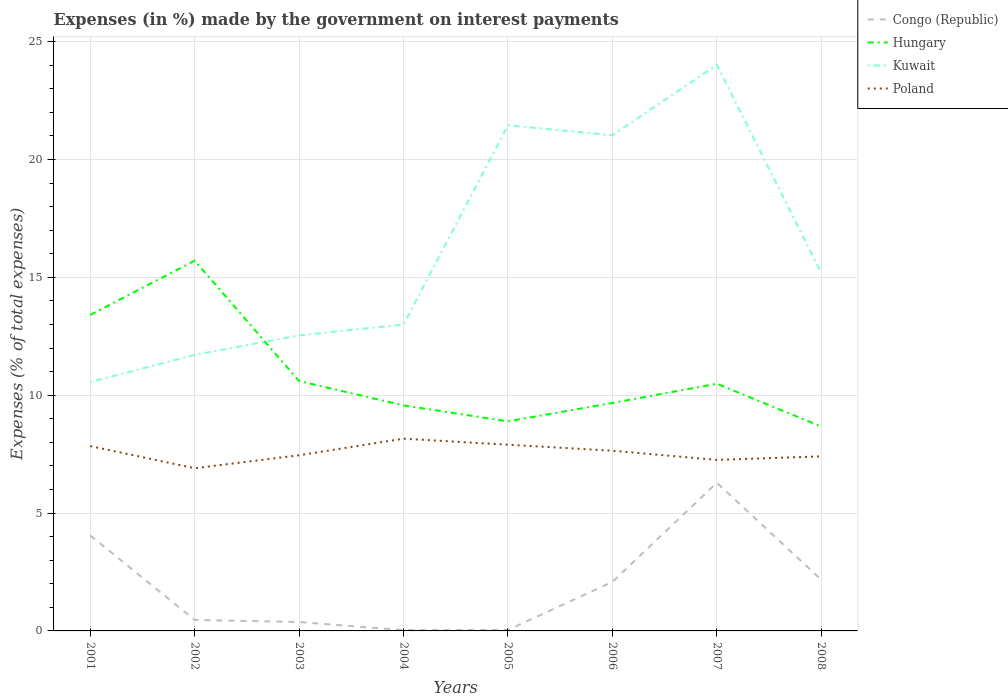Does the line corresponding to Hungary intersect with the line corresponding to Congo (Republic)?
Provide a short and direct response. No. Is the number of lines equal to the number of legend labels?
Provide a succinct answer. Yes. Across all years, what is the maximum percentage of expenses made by the government on interest payments in Kuwait?
Provide a succinct answer. 10.56. In which year was the percentage of expenses made by the government on interest payments in Congo (Republic) maximum?
Keep it short and to the point. 2004. What is the total percentage of expenses made by the government on interest payments in Congo (Republic) in the graph?
Ensure brevity in your answer.  4.02. What is the difference between the highest and the second highest percentage of expenses made by the government on interest payments in Kuwait?
Offer a terse response. 13.45. What is the difference between the highest and the lowest percentage of expenses made by the government on interest payments in Poland?
Provide a succinct answer. 4. How many lines are there?
Your answer should be compact. 4. Are the values on the major ticks of Y-axis written in scientific E-notation?
Offer a very short reply. No. Where does the legend appear in the graph?
Give a very brief answer. Top right. How many legend labels are there?
Offer a terse response. 4. How are the legend labels stacked?
Your response must be concise. Vertical. What is the title of the graph?
Ensure brevity in your answer.  Expenses (in %) made by the government on interest payments. What is the label or title of the Y-axis?
Offer a very short reply. Expenses (% of total expenses). What is the Expenses (% of total expenses) of Congo (Republic) in 2001?
Make the answer very short. 4.05. What is the Expenses (% of total expenses) in Hungary in 2001?
Provide a succinct answer. 13.41. What is the Expenses (% of total expenses) of Kuwait in 2001?
Provide a short and direct response. 10.56. What is the Expenses (% of total expenses) in Poland in 2001?
Ensure brevity in your answer.  7.84. What is the Expenses (% of total expenses) of Congo (Republic) in 2002?
Ensure brevity in your answer.  0.47. What is the Expenses (% of total expenses) in Hungary in 2002?
Offer a very short reply. 15.71. What is the Expenses (% of total expenses) in Kuwait in 2002?
Offer a very short reply. 11.71. What is the Expenses (% of total expenses) in Poland in 2002?
Ensure brevity in your answer.  6.9. What is the Expenses (% of total expenses) of Congo (Republic) in 2003?
Offer a terse response. 0.38. What is the Expenses (% of total expenses) in Hungary in 2003?
Make the answer very short. 10.6. What is the Expenses (% of total expenses) of Kuwait in 2003?
Keep it short and to the point. 12.54. What is the Expenses (% of total expenses) in Poland in 2003?
Make the answer very short. 7.45. What is the Expenses (% of total expenses) of Congo (Republic) in 2004?
Offer a very short reply. 0.03. What is the Expenses (% of total expenses) in Hungary in 2004?
Your response must be concise. 9.57. What is the Expenses (% of total expenses) in Kuwait in 2004?
Provide a succinct answer. 13. What is the Expenses (% of total expenses) of Poland in 2004?
Ensure brevity in your answer.  8.16. What is the Expenses (% of total expenses) in Congo (Republic) in 2005?
Offer a terse response. 0.04. What is the Expenses (% of total expenses) in Hungary in 2005?
Your answer should be compact. 8.89. What is the Expenses (% of total expenses) in Kuwait in 2005?
Keep it short and to the point. 21.45. What is the Expenses (% of total expenses) of Poland in 2005?
Your answer should be very brief. 7.9. What is the Expenses (% of total expenses) in Congo (Republic) in 2006?
Your answer should be compact. 2.08. What is the Expenses (% of total expenses) of Hungary in 2006?
Make the answer very short. 9.67. What is the Expenses (% of total expenses) in Kuwait in 2006?
Provide a short and direct response. 21.03. What is the Expenses (% of total expenses) in Poland in 2006?
Keep it short and to the point. 7.64. What is the Expenses (% of total expenses) in Congo (Republic) in 2007?
Provide a succinct answer. 6.29. What is the Expenses (% of total expenses) in Hungary in 2007?
Make the answer very short. 10.49. What is the Expenses (% of total expenses) in Kuwait in 2007?
Your answer should be compact. 24.01. What is the Expenses (% of total expenses) of Poland in 2007?
Provide a short and direct response. 7.26. What is the Expenses (% of total expenses) in Congo (Republic) in 2008?
Provide a succinct answer. 2.17. What is the Expenses (% of total expenses) in Hungary in 2008?
Provide a succinct answer. 8.67. What is the Expenses (% of total expenses) of Kuwait in 2008?
Your answer should be very brief. 15.19. What is the Expenses (% of total expenses) in Poland in 2008?
Offer a very short reply. 7.4. Across all years, what is the maximum Expenses (% of total expenses) in Congo (Republic)?
Your response must be concise. 6.29. Across all years, what is the maximum Expenses (% of total expenses) of Hungary?
Your response must be concise. 15.71. Across all years, what is the maximum Expenses (% of total expenses) in Kuwait?
Ensure brevity in your answer.  24.01. Across all years, what is the maximum Expenses (% of total expenses) of Poland?
Make the answer very short. 8.16. Across all years, what is the minimum Expenses (% of total expenses) in Congo (Republic)?
Offer a very short reply. 0.03. Across all years, what is the minimum Expenses (% of total expenses) in Hungary?
Offer a terse response. 8.67. Across all years, what is the minimum Expenses (% of total expenses) of Kuwait?
Ensure brevity in your answer.  10.56. Across all years, what is the minimum Expenses (% of total expenses) of Poland?
Your response must be concise. 6.9. What is the total Expenses (% of total expenses) of Congo (Republic) in the graph?
Provide a short and direct response. 15.5. What is the total Expenses (% of total expenses) in Hungary in the graph?
Offer a terse response. 86.99. What is the total Expenses (% of total expenses) in Kuwait in the graph?
Keep it short and to the point. 129.49. What is the total Expenses (% of total expenses) in Poland in the graph?
Offer a very short reply. 60.55. What is the difference between the Expenses (% of total expenses) of Congo (Republic) in 2001 and that in 2002?
Ensure brevity in your answer.  3.58. What is the difference between the Expenses (% of total expenses) in Kuwait in 2001 and that in 2002?
Your response must be concise. -1.15. What is the difference between the Expenses (% of total expenses) in Poland in 2001 and that in 2002?
Make the answer very short. 0.94. What is the difference between the Expenses (% of total expenses) of Congo (Republic) in 2001 and that in 2003?
Make the answer very short. 3.67. What is the difference between the Expenses (% of total expenses) in Hungary in 2001 and that in 2003?
Your answer should be compact. 2.8. What is the difference between the Expenses (% of total expenses) in Kuwait in 2001 and that in 2003?
Provide a succinct answer. -1.98. What is the difference between the Expenses (% of total expenses) in Poland in 2001 and that in 2003?
Give a very brief answer. 0.39. What is the difference between the Expenses (% of total expenses) in Congo (Republic) in 2001 and that in 2004?
Your answer should be very brief. 4.02. What is the difference between the Expenses (% of total expenses) in Hungary in 2001 and that in 2004?
Keep it short and to the point. 3.84. What is the difference between the Expenses (% of total expenses) in Kuwait in 2001 and that in 2004?
Your response must be concise. -2.44. What is the difference between the Expenses (% of total expenses) in Poland in 2001 and that in 2004?
Your answer should be compact. -0.31. What is the difference between the Expenses (% of total expenses) of Congo (Republic) in 2001 and that in 2005?
Give a very brief answer. 4.01. What is the difference between the Expenses (% of total expenses) of Hungary in 2001 and that in 2005?
Ensure brevity in your answer.  4.51. What is the difference between the Expenses (% of total expenses) in Kuwait in 2001 and that in 2005?
Offer a very short reply. -10.89. What is the difference between the Expenses (% of total expenses) in Poland in 2001 and that in 2005?
Offer a very short reply. -0.06. What is the difference between the Expenses (% of total expenses) in Congo (Republic) in 2001 and that in 2006?
Provide a succinct answer. 1.97. What is the difference between the Expenses (% of total expenses) of Hungary in 2001 and that in 2006?
Your answer should be compact. 3.73. What is the difference between the Expenses (% of total expenses) of Kuwait in 2001 and that in 2006?
Offer a very short reply. -10.47. What is the difference between the Expenses (% of total expenses) in Poland in 2001 and that in 2006?
Your response must be concise. 0.2. What is the difference between the Expenses (% of total expenses) of Congo (Republic) in 2001 and that in 2007?
Offer a terse response. -2.24. What is the difference between the Expenses (% of total expenses) of Hungary in 2001 and that in 2007?
Offer a very short reply. 2.92. What is the difference between the Expenses (% of total expenses) in Kuwait in 2001 and that in 2007?
Your response must be concise. -13.45. What is the difference between the Expenses (% of total expenses) of Poland in 2001 and that in 2007?
Provide a short and direct response. 0.59. What is the difference between the Expenses (% of total expenses) in Congo (Republic) in 2001 and that in 2008?
Give a very brief answer. 1.88. What is the difference between the Expenses (% of total expenses) of Hungary in 2001 and that in 2008?
Offer a very short reply. 4.73. What is the difference between the Expenses (% of total expenses) of Kuwait in 2001 and that in 2008?
Offer a very short reply. -4.63. What is the difference between the Expenses (% of total expenses) of Poland in 2001 and that in 2008?
Make the answer very short. 0.44. What is the difference between the Expenses (% of total expenses) of Congo (Republic) in 2002 and that in 2003?
Offer a very short reply. 0.09. What is the difference between the Expenses (% of total expenses) of Hungary in 2002 and that in 2003?
Offer a very short reply. 5.1. What is the difference between the Expenses (% of total expenses) in Kuwait in 2002 and that in 2003?
Give a very brief answer. -0.83. What is the difference between the Expenses (% of total expenses) in Poland in 2002 and that in 2003?
Keep it short and to the point. -0.55. What is the difference between the Expenses (% of total expenses) in Congo (Republic) in 2002 and that in 2004?
Your response must be concise. 0.43. What is the difference between the Expenses (% of total expenses) of Hungary in 2002 and that in 2004?
Provide a succinct answer. 6.14. What is the difference between the Expenses (% of total expenses) in Kuwait in 2002 and that in 2004?
Provide a succinct answer. -1.29. What is the difference between the Expenses (% of total expenses) of Poland in 2002 and that in 2004?
Ensure brevity in your answer.  -1.25. What is the difference between the Expenses (% of total expenses) in Congo (Republic) in 2002 and that in 2005?
Your response must be concise. 0.42. What is the difference between the Expenses (% of total expenses) of Hungary in 2002 and that in 2005?
Ensure brevity in your answer.  6.81. What is the difference between the Expenses (% of total expenses) in Kuwait in 2002 and that in 2005?
Ensure brevity in your answer.  -9.74. What is the difference between the Expenses (% of total expenses) of Poland in 2002 and that in 2005?
Provide a short and direct response. -1. What is the difference between the Expenses (% of total expenses) of Congo (Republic) in 2002 and that in 2006?
Provide a succinct answer. -1.61. What is the difference between the Expenses (% of total expenses) of Hungary in 2002 and that in 2006?
Make the answer very short. 6.03. What is the difference between the Expenses (% of total expenses) of Kuwait in 2002 and that in 2006?
Offer a terse response. -9.32. What is the difference between the Expenses (% of total expenses) in Poland in 2002 and that in 2006?
Provide a succinct answer. -0.74. What is the difference between the Expenses (% of total expenses) in Congo (Republic) in 2002 and that in 2007?
Keep it short and to the point. -5.82. What is the difference between the Expenses (% of total expenses) of Hungary in 2002 and that in 2007?
Offer a very short reply. 5.22. What is the difference between the Expenses (% of total expenses) in Kuwait in 2002 and that in 2007?
Offer a very short reply. -12.3. What is the difference between the Expenses (% of total expenses) in Poland in 2002 and that in 2007?
Your answer should be compact. -0.35. What is the difference between the Expenses (% of total expenses) in Congo (Republic) in 2002 and that in 2008?
Give a very brief answer. -1.71. What is the difference between the Expenses (% of total expenses) in Hungary in 2002 and that in 2008?
Your response must be concise. 7.03. What is the difference between the Expenses (% of total expenses) in Kuwait in 2002 and that in 2008?
Provide a short and direct response. -3.49. What is the difference between the Expenses (% of total expenses) in Poland in 2002 and that in 2008?
Keep it short and to the point. -0.5. What is the difference between the Expenses (% of total expenses) of Congo (Republic) in 2003 and that in 2004?
Offer a very short reply. 0.34. What is the difference between the Expenses (% of total expenses) in Hungary in 2003 and that in 2004?
Your answer should be very brief. 1.03. What is the difference between the Expenses (% of total expenses) of Kuwait in 2003 and that in 2004?
Provide a short and direct response. -0.46. What is the difference between the Expenses (% of total expenses) in Poland in 2003 and that in 2004?
Your answer should be very brief. -0.7. What is the difference between the Expenses (% of total expenses) of Congo (Republic) in 2003 and that in 2005?
Your response must be concise. 0.33. What is the difference between the Expenses (% of total expenses) in Hungary in 2003 and that in 2005?
Provide a succinct answer. 1.71. What is the difference between the Expenses (% of total expenses) in Kuwait in 2003 and that in 2005?
Give a very brief answer. -8.91. What is the difference between the Expenses (% of total expenses) of Poland in 2003 and that in 2005?
Provide a short and direct response. -0.45. What is the difference between the Expenses (% of total expenses) of Congo (Republic) in 2003 and that in 2006?
Your response must be concise. -1.7. What is the difference between the Expenses (% of total expenses) of Hungary in 2003 and that in 2006?
Provide a succinct answer. 0.93. What is the difference between the Expenses (% of total expenses) of Kuwait in 2003 and that in 2006?
Provide a short and direct response. -8.49. What is the difference between the Expenses (% of total expenses) of Poland in 2003 and that in 2006?
Make the answer very short. -0.19. What is the difference between the Expenses (% of total expenses) in Congo (Republic) in 2003 and that in 2007?
Provide a succinct answer. -5.91. What is the difference between the Expenses (% of total expenses) of Hungary in 2003 and that in 2007?
Your response must be concise. 0.11. What is the difference between the Expenses (% of total expenses) of Kuwait in 2003 and that in 2007?
Provide a succinct answer. -11.48. What is the difference between the Expenses (% of total expenses) of Poland in 2003 and that in 2007?
Provide a succinct answer. 0.2. What is the difference between the Expenses (% of total expenses) in Congo (Republic) in 2003 and that in 2008?
Keep it short and to the point. -1.8. What is the difference between the Expenses (% of total expenses) of Hungary in 2003 and that in 2008?
Ensure brevity in your answer.  1.93. What is the difference between the Expenses (% of total expenses) of Kuwait in 2003 and that in 2008?
Provide a short and direct response. -2.66. What is the difference between the Expenses (% of total expenses) of Poland in 2003 and that in 2008?
Keep it short and to the point. 0.05. What is the difference between the Expenses (% of total expenses) of Congo (Republic) in 2004 and that in 2005?
Give a very brief answer. -0.01. What is the difference between the Expenses (% of total expenses) of Hungary in 2004 and that in 2005?
Offer a terse response. 0.68. What is the difference between the Expenses (% of total expenses) of Kuwait in 2004 and that in 2005?
Offer a very short reply. -8.45. What is the difference between the Expenses (% of total expenses) in Poland in 2004 and that in 2005?
Provide a short and direct response. 0.26. What is the difference between the Expenses (% of total expenses) in Congo (Republic) in 2004 and that in 2006?
Offer a very short reply. -2.04. What is the difference between the Expenses (% of total expenses) of Hungary in 2004 and that in 2006?
Ensure brevity in your answer.  -0.1. What is the difference between the Expenses (% of total expenses) of Kuwait in 2004 and that in 2006?
Offer a very short reply. -8.03. What is the difference between the Expenses (% of total expenses) of Poland in 2004 and that in 2006?
Keep it short and to the point. 0.51. What is the difference between the Expenses (% of total expenses) in Congo (Republic) in 2004 and that in 2007?
Provide a short and direct response. -6.25. What is the difference between the Expenses (% of total expenses) of Hungary in 2004 and that in 2007?
Your response must be concise. -0.92. What is the difference between the Expenses (% of total expenses) in Kuwait in 2004 and that in 2007?
Keep it short and to the point. -11.02. What is the difference between the Expenses (% of total expenses) of Poland in 2004 and that in 2007?
Your answer should be very brief. 0.9. What is the difference between the Expenses (% of total expenses) of Congo (Republic) in 2004 and that in 2008?
Ensure brevity in your answer.  -2.14. What is the difference between the Expenses (% of total expenses) in Hungary in 2004 and that in 2008?
Offer a very short reply. 0.89. What is the difference between the Expenses (% of total expenses) of Kuwait in 2004 and that in 2008?
Ensure brevity in your answer.  -2.2. What is the difference between the Expenses (% of total expenses) of Poland in 2004 and that in 2008?
Give a very brief answer. 0.75. What is the difference between the Expenses (% of total expenses) in Congo (Republic) in 2005 and that in 2006?
Make the answer very short. -2.04. What is the difference between the Expenses (% of total expenses) in Hungary in 2005 and that in 2006?
Give a very brief answer. -0.78. What is the difference between the Expenses (% of total expenses) of Kuwait in 2005 and that in 2006?
Make the answer very short. 0.42. What is the difference between the Expenses (% of total expenses) of Poland in 2005 and that in 2006?
Make the answer very short. 0.25. What is the difference between the Expenses (% of total expenses) in Congo (Republic) in 2005 and that in 2007?
Ensure brevity in your answer.  -6.24. What is the difference between the Expenses (% of total expenses) in Hungary in 2005 and that in 2007?
Offer a terse response. -1.6. What is the difference between the Expenses (% of total expenses) of Kuwait in 2005 and that in 2007?
Your answer should be compact. -2.56. What is the difference between the Expenses (% of total expenses) in Poland in 2005 and that in 2007?
Give a very brief answer. 0.64. What is the difference between the Expenses (% of total expenses) in Congo (Republic) in 2005 and that in 2008?
Ensure brevity in your answer.  -2.13. What is the difference between the Expenses (% of total expenses) in Hungary in 2005 and that in 2008?
Your answer should be very brief. 0.22. What is the difference between the Expenses (% of total expenses) of Kuwait in 2005 and that in 2008?
Offer a terse response. 6.26. What is the difference between the Expenses (% of total expenses) of Poland in 2005 and that in 2008?
Your response must be concise. 0.49. What is the difference between the Expenses (% of total expenses) of Congo (Republic) in 2006 and that in 2007?
Your response must be concise. -4.21. What is the difference between the Expenses (% of total expenses) of Hungary in 2006 and that in 2007?
Offer a very short reply. -0.82. What is the difference between the Expenses (% of total expenses) in Kuwait in 2006 and that in 2007?
Ensure brevity in your answer.  -2.99. What is the difference between the Expenses (% of total expenses) in Poland in 2006 and that in 2007?
Provide a succinct answer. 0.39. What is the difference between the Expenses (% of total expenses) in Congo (Republic) in 2006 and that in 2008?
Provide a short and direct response. -0.09. What is the difference between the Expenses (% of total expenses) in Hungary in 2006 and that in 2008?
Keep it short and to the point. 1. What is the difference between the Expenses (% of total expenses) in Kuwait in 2006 and that in 2008?
Your answer should be compact. 5.83. What is the difference between the Expenses (% of total expenses) of Poland in 2006 and that in 2008?
Your answer should be very brief. 0.24. What is the difference between the Expenses (% of total expenses) of Congo (Republic) in 2007 and that in 2008?
Make the answer very short. 4.11. What is the difference between the Expenses (% of total expenses) in Hungary in 2007 and that in 2008?
Keep it short and to the point. 1.82. What is the difference between the Expenses (% of total expenses) in Kuwait in 2007 and that in 2008?
Provide a succinct answer. 8.82. What is the difference between the Expenses (% of total expenses) of Poland in 2007 and that in 2008?
Provide a short and direct response. -0.15. What is the difference between the Expenses (% of total expenses) of Congo (Republic) in 2001 and the Expenses (% of total expenses) of Hungary in 2002?
Offer a very short reply. -11.66. What is the difference between the Expenses (% of total expenses) of Congo (Republic) in 2001 and the Expenses (% of total expenses) of Kuwait in 2002?
Provide a short and direct response. -7.66. What is the difference between the Expenses (% of total expenses) of Congo (Republic) in 2001 and the Expenses (% of total expenses) of Poland in 2002?
Give a very brief answer. -2.85. What is the difference between the Expenses (% of total expenses) in Hungary in 2001 and the Expenses (% of total expenses) in Kuwait in 2002?
Your response must be concise. 1.7. What is the difference between the Expenses (% of total expenses) in Hungary in 2001 and the Expenses (% of total expenses) in Poland in 2002?
Keep it short and to the point. 6.5. What is the difference between the Expenses (% of total expenses) in Kuwait in 2001 and the Expenses (% of total expenses) in Poland in 2002?
Ensure brevity in your answer.  3.66. What is the difference between the Expenses (% of total expenses) of Congo (Republic) in 2001 and the Expenses (% of total expenses) of Hungary in 2003?
Offer a very short reply. -6.55. What is the difference between the Expenses (% of total expenses) in Congo (Republic) in 2001 and the Expenses (% of total expenses) in Kuwait in 2003?
Keep it short and to the point. -8.49. What is the difference between the Expenses (% of total expenses) of Congo (Republic) in 2001 and the Expenses (% of total expenses) of Poland in 2003?
Give a very brief answer. -3.4. What is the difference between the Expenses (% of total expenses) in Hungary in 2001 and the Expenses (% of total expenses) in Kuwait in 2003?
Offer a very short reply. 0.87. What is the difference between the Expenses (% of total expenses) of Hungary in 2001 and the Expenses (% of total expenses) of Poland in 2003?
Provide a short and direct response. 5.95. What is the difference between the Expenses (% of total expenses) of Kuwait in 2001 and the Expenses (% of total expenses) of Poland in 2003?
Keep it short and to the point. 3.11. What is the difference between the Expenses (% of total expenses) in Congo (Republic) in 2001 and the Expenses (% of total expenses) in Hungary in 2004?
Your response must be concise. -5.52. What is the difference between the Expenses (% of total expenses) in Congo (Republic) in 2001 and the Expenses (% of total expenses) in Kuwait in 2004?
Keep it short and to the point. -8.95. What is the difference between the Expenses (% of total expenses) of Congo (Republic) in 2001 and the Expenses (% of total expenses) of Poland in 2004?
Provide a succinct answer. -4.11. What is the difference between the Expenses (% of total expenses) of Hungary in 2001 and the Expenses (% of total expenses) of Kuwait in 2004?
Ensure brevity in your answer.  0.41. What is the difference between the Expenses (% of total expenses) in Hungary in 2001 and the Expenses (% of total expenses) in Poland in 2004?
Your answer should be very brief. 5.25. What is the difference between the Expenses (% of total expenses) of Kuwait in 2001 and the Expenses (% of total expenses) of Poland in 2004?
Ensure brevity in your answer.  2.4. What is the difference between the Expenses (% of total expenses) in Congo (Republic) in 2001 and the Expenses (% of total expenses) in Hungary in 2005?
Ensure brevity in your answer.  -4.84. What is the difference between the Expenses (% of total expenses) of Congo (Republic) in 2001 and the Expenses (% of total expenses) of Kuwait in 2005?
Ensure brevity in your answer.  -17.4. What is the difference between the Expenses (% of total expenses) in Congo (Republic) in 2001 and the Expenses (% of total expenses) in Poland in 2005?
Make the answer very short. -3.85. What is the difference between the Expenses (% of total expenses) of Hungary in 2001 and the Expenses (% of total expenses) of Kuwait in 2005?
Provide a succinct answer. -8.04. What is the difference between the Expenses (% of total expenses) of Hungary in 2001 and the Expenses (% of total expenses) of Poland in 2005?
Keep it short and to the point. 5.51. What is the difference between the Expenses (% of total expenses) in Kuwait in 2001 and the Expenses (% of total expenses) in Poland in 2005?
Offer a very short reply. 2.66. What is the difference between the Expenses (% of total expenses) of Congo (Republic) in 2001 and the Expenses (% of total expenses) of Hungary in 2006?
Ensure brevity in your answer.  -5.62. What is the difference between the Expenses (% of total expenses) of Congo (Republic) in 2001 and the Expenses (% of total expenses) of Kuwait in 2006?
Your answer should be compact. -16.98. What is the difference between the Expenses (% of total expenses) in Congo (Republic) in 2001 and the Expenses (% of total expenses) in Poland in 2006?
Provide a short and direct response. -3.6. What is the difference between the Expenses (% of total expenses) of Hungary in 2001 and the Expenses (% of total expenses) of Kuwait in 2006?
Keep it short and to the point. -7.62. What is the difference between the Expenses (% of total expenses) of Hungary in 2001 and the Expenses (% of total expenses) of Poland in 2006?
Offer a terse response. 5.76. What is the difference between the Expenses (% of total expenses) in Kuwait in 2001 and the Expenses (% of total expenses) in Poland in 2006?
Provide a succinct answer. 2.92. What is the difference between the Expenses (% of total expenses) of Congo (Republic) in 2001 and the Expenses (% of total expenses) of Hungary in 2007?
Keep it short and to the point. -6.44. What is the difference between the Expenses (% of total expenses) in Congo (Republic) in 2001 and the Expenses (% of total expenses) in Kuwait in 2007?
Ensure brevity in your answer.  -19.96. What is the difference between the Expenses (% of total expenses) of Congo (Republic) in 2001 and the Expenses (% of total expenses) of Poland in 2007?
Offer a very short reply. -3.21. What is the difference between the Expenses (% of total expenses) of Hungary in 2001 and the Expenses (% of total expenses) of Kuwait in 2007?
Provide a short and direct response. -10.61. What is the difference between the Expenses (% of total expenses) in Hungary in 2001 and the Expenses (% of total expenses) in Poland in 2007?
Your response must be concise. 6.15. What is the difference between the Expenses (% of total expenses) in Kuwait in 2001 and the Expenses (% of total expenses) in Poland in 2007?
Provide a short and direct response. 3.31. What is the difference between the Expenses (% of total expenses) in Congo (Republic) in 2001 and the Expenses (% of total expenses) in Hungary in 2008?
Keep it short and to the point. -4.62. What is the difference between the Expenses (% of total expenses) of Congo (Republic) in 2001 and the Expenses (% of total expenses) of Kuwait in 2008?
Keep it short and to the point. -11.15. What is the difference between the Expenses (% of total expenses) of Congo (Republic) in 2001 and the Expenses (% of total expenses) of Poland in 2008?
Give a very brief answer. -3.36. What is the difference between the Expenses (% of total expenses) of Hungary in 2001 and the Expenses (% of total expenses) of Kuwait in 2008?
Ensure brevity in your answer.  -1.79. What is the difference between the Expenses (% of total expenses) in Hungary in 2001 and the Expenses (% of total expenses) in Poland in 2008?
Ensure brevity in your answer.  6. What is the difference between the Expenses (% of total expenses) of Kuwait in 2001 and the Expenses (% of total expenses) of Poland in 2008?
Keep it short and to the point. 3.16. What is the difference between the Expenses (% of total expenses) in Congo (Republic) in 2002 and the Expenses (% of total expenses) in Hungary in 2003?
Your answer should be very brief. -10.13. What is the difference between the Expenses (% of total expenses) in Congo (Republic) in 2002 and the Expenses (% of total expenses) in Kuwait in 2003?
Your answer should be very brief. -12.07. What is the difference between the Expenses (% of total expenses) in Congo (Republic) in 2002 and the Expenses (% of total expenses) in Poland in 2003?
Make the answer very short. -6.99. What is the difference between the Expenses (% of total expenses) in Hungary in 2002 and the Expenses (% of total expenses) in Kuwait in 2003?
Provide a succinct answer. 3.17. What is the difference between the Expenses (% of total expenses) in Hungary in 2002 and the Expenses (% of total expenses) in Poland in 2003?
Offer a terse response. 8.25. What is the difference between the Expenses (% of total expenses) in Kuwait in 2002 and the Expenses (% of total expenses) in Poland in 2003?
Give a very brief answer. 4.26. What is the difference between the Expenses (% of total expenses) in Congo (Republic) in 2002 and the Expenses (% of total expenses) in Hungary in 2004?
Keep it short and to the point. -9.1. What is the difference between the Expenses (% of total expenses) of Congo (Republic) in 2002 and the Expenses (% of total expenses) of Kuwait in 2004?
Offer a terse response. -12.53. What is the difference between the Expenses (% of total expenses) in Congo (Republic) in 2002 and the Expenses (% of total expenses) in Poland in 2004?
Ensure brevity in your answer.  -7.69. What is the difference between the Expenses (% of total expenses) of Hungary in 2002 and the Expenses (% of total expenses) of Kuwait in 2004?
Give a very brief answer. 2.71. What is the difference between the Expenses (% of total expenses) of Hungary in 2002 and the Expenses (% of total expenses) of Poland in 2004?
Offer a very short reply. 7.55. What is the difference between the Expenses (% of total expenses) of Kuwait in 2002 and the Expenses (% of total expenses) of Poland in 2004?
Your answer should be very brief. 3.55. What is the difference between the Expenses (% of total expenses) in Congo (Republic) in 2002 and the Expenses (% of total expenses) in Hungary in 2005?
Provide a succinct answer. -8.42. What is the difference between the Expenses (% of total expenses) in Congo (Republic) in 2002 and the Expenses (% of total expenses) in Kuwait in 2005?
Offer a very short reply. -20.98. What is the difference between the Expenses (% of total expenses) in Congo (Republic) in 2002 and the Expenses (% of total expenses) in Poland in 2005?
Provide a short and direct response. -7.43. What is the difference between the Expenses (% of total expenses) of Hungary in 2002 and the Expenses (% of total expenses) of Kuwait in 2005?
Your answer should be very brief. -5.74. What is the difference between the Expenses (% of total expenses) of Hungary in 2002 and the Expenses (% of total expenses) of Poland in 2005?
Offer a very short reply. 7.81. What is the difference between the Expenses (% of total expenses) of Kuwait in 2002 and the Expenses (% of total expenses) of Poland in 2005?
Offer a very short reply. 3.81. What is the difference between the Expenses (% of total expenses) in Congo (Republic) in 2002 and the Expenses (% of total expenses) in Hungary in 2006?
Make the answer very short. -9.2. What is the difference between the Expenses (% of total expenses) of Congo (Republic) in 2002 and the Expenses (% of total expenses) of Kuwait in 2006?
Make the answer very short. -20.56. What is the difference between the Expenses (% of total expenses) of Congo (Republic) in 2002 and the Expenses (% of total expenses) of Poland in 2006?
Keep it short and to the point. -7.18. What is the difference between the Expenses (% of total expenses) of Hungary in 2002 and the Expenses (% of total expenses) of Kuwait in 2006?
Provide a succinct answer. -5.32. What is the difference between the Expenses (% of total expenses) of Hungary in 2002 and the Expenses (% of total expenses) of Poland in 2006?
Your answer should be very brief. 8.06. What is the difference between the Expenses (% of total expenses) in Kuwait in 2002 and the Expenses (% of total expenses) in Poland in 2006?
Offer a terse response. 4.06. What is the difference between the Expenses (% of total expenses) in Congo (Republic) in 2002 and the Expenses (% of total expenses) in Hungary in 2007?
Offer a very short reply. -10.02. What is the difference between the Expenses (% of total expenses) in Congo (Republic) in 2002 and the Expenses (% of total expenses) in Kuwait in 2007?
Your response must be concise. -23.55. What is the difference between the Expenses (% of total expenses) of Congo (Republic) in 2002 and the Expenses (% of total expenses) of Poland in 2007?
Ensure brevity in your answer.  -6.79. What is the difference between the Expenses (% of total expenses) of Hungary in 2002 and the Expenses (% of total expenses) of Kuwait in 2007?
Your answer should be very brief. -8.31. What is the difference between the Expenses (% of total expenses) in Hungary in 2002 and the Expenses (% of total expenses) in Poland in 2007?
Offer a very short reply. 8.45. What is the difference between the Expenses (% of total expenses) of Kuwait in 2002 and the Expenses (% of total expenses) of Poland in 2007?
Ensure brevity in your answer.  4.45. What is the difference between the Expenses (% of total expenses) of Congo (Republic) in 2002 and the Expenses (% of total expenses) of Hungary in 2008?
Offer a terse response. -8.2. What is the difference between the Expenses (% of total expenses) in Congo (Republic) in 2002 and the Expenses (% of total expenses) in Kuwait in 2008?
Give a very brief answer. -14.73. What is the difference between the Expenses (% of total expenses) in Congo (Republic) in 2002 and the Expenses (% of total expenses) in Poland in 2008?
Offer a very short reply. -6.94. What is the difference between the Expenses (% of total expenses) of Hungary in 2002 and the Expenses (% of total expenses) of Kuwait in 2008?
Provide a short and direct response. 0.51. What is the difference between the Expenses (% of total expenses) of Hungary in 2002 and the Expenses (% of total expenses) of Poland in 2008?
Your response must be concise. 8.3. What is the difference between the Expenses (% of total expenses) of Kuwait in 2002 and the Expenses (% of total expenses) of Poland in 2008?
Your answer should be compact. 4.3. What is the difference between the Expenses (% of total expenses) of Congo (Republic) in 2003 and the Expenses (% of total expenses) of Hungary in 2004?
Your answer should be compact. -9.19. What is the difference between the Expenses (% of total expenses) of Congo (Republic) in 2003 and the Expenses (% of total expenses) of Kuwait in 2004?
Offer a terse response. -12.62. What is the difference between the Expenses (% of total expenses) of Congo (Republic) in 2003 and the Expenses (% of total expenses) of Poland in 2004?
Provide a succinct answer. -7.78. What is the difference between the Expenses (% of total expenses) in Hungary in 2003 and the Expenses (% of total expenses) in Kuwait in 2004?
Your response must be concise. -2.4. What is the difference between the Expenses (% of total expenses) in Hungary in 2003 and the Expenses (% of total expenses) in Poland in 2004?
Offer a very short reply. 2.45. What is the difference between the Expenses (% of total expenses) in Kuwait in 2003 and the Expenses (% of total expenses) in Poland in 2004?
Your answer should be compact. 4.38. What is the difference between the Expenses (% of total expenses) in Congo (Republic) in 2003 and the Expenses (% of total expenses) in Hungary in 2005?
Offer a terse response. -8.51. What is the difference between the Expenses (% of total expenses) of Congo (Republic) in 2003 and the Expenses (% of total expenses) of Kuwait in 2005?
Offer a very short reply. -21.07. What is the difference between the Expenses (% of total expenses) in Congo (Republic) in 2003 and the Expenses (% of total expenses) in Poland in 2005?
Your answer should be compact. -7.52. What is the difference between the Expenses (% of total expenses) of Hungary in 2003 and the Expenses (% of total expenses) of Kuwait in 2005?
Your answer should be very brief. -10.85. What is the difference between the Expenses (% of total expenses) in Hungary in 2003 and the Expenses (% of total expenses) in Poland in 2005?
Your answer should be compact. 2.7. What is the difference between the Expenses (% of total expenses) in Kuwait in 2003 and the Expenses (% of total expenses) in Poland in 2005?
Ensure brevity in your answer.  4.64. What is the difference between the Expenses (% of total expenses) in Congo (Republic) in 2003 and the Expenses (% of total expenses) in Hungary in 2006?
Ensure brevity in your answer.  -9.29. What is the difference between the Expenses (% of total expenses) of Congo (Republic) in 2003 and the Expenses (% of total expenses) of Kuwait in 2006?
Provide a short and direct response. -20.65. What is the difference between the Expenses (% of total expenses) in Congo (Republic) in 2003 and the Expenses (% of total expenses) in Poland in 2006?
Ensure brevity in your answer.  -7.27. What is the difference between the Expenses (% of total expenses) of Hungary in 2003 and the Expenses (% of total expenses) of Kuwait in 2006?
Offer a very short reply. -10.43. What is the difference between the Expenses (% of total expenses) in Hungary in 2003 and the Expenses (% of total expenses) in Poland in 2006?
Your answer should be very brief. 2.96. What is the difference between the Expenses (% of total expenses) of Kuwait in 2003 and the Expenses (% of total expenses) of Poland in 2006?
Ensure brevity in your answer.  4.89. What is the difference between the Expenses (% of total expenses) in Congo (Republic) in 2003 and the Expenses (% of total expenses) in Hungary in 2007?
Provide a succinct answer. -10.11. What is the difference between the Expenses (% of total expenses) in Congo (Republic) in 2003 and the Expenses (% of total expenses) in Kuwait in 2007?
Provide a short and direct response. -23.64. What is the difference between the Expenses (% of total expenses) in Congo (Republic) in 2003 and the Expenses (% of total expenses) in Poland in 2007?
Your response must be concise. -6.88. What is the difference between the Expenses (% of total expenses) in Hungary in 2003 and the Expenses (% of total expenses) in Kuwait in 2007?
Ensure brevity in your answer.  -13.41. What is the difference between the Expenses (% of total expenses) in Hungary in 2003 and the Expenses (% of total expenses) in Poland in 2007?
Provide a short and direct response. 3.35. What is the difference between the Expenses (% of total expenses) in Kuwait in 2003 and the Expenses (% of total expenses) in Poland in 2007?
Provide a short and direct response. 5.28. What is the difference between the Expenses (% of total expenses) of Congo (Republic) in 2003 and the Expenses (% of total expenses) of Hungary in 2008?
Your answer should be compact. -8.29. What is the difference between the Expenses (% of total expenses) in Congo (Republic) in 2003 and the Expenses (% of total expenses) in Kuwait in 2008?
Provide a short and direct response. -14.82. What is the difference between the Expenses (% of total expenses) in Congo (Republic) in 2003 and the Expenses (% of total expenses) in Poland in 2008?
Offer a terse response. -7.03. What is the difference between the Expenses (% of total expenses) in Hungary in 2003 and the Expenses (% of total expenses) in Kuwait in 2008?
Keep it short and to the point. -4.59. What is the difference between the Expenses (% of total expenses) in Hungary in 2003 and the Expenses (% of total expenses) in Poland in 2008?
Give a very brief answer. 3.2. What is the difference between the Expenses (% of total expenses) in Kuwait in 2003 and the Expenses (% of total expenses) in Poland in 2008?
Your answer should be compact. 5.13. What is the difference between the Expenses (% of total expenses) of Congo (Republic) in 2004 and the Expenses (% of total expenses) of Hungary in 2005?
Your answer should be compact. -8.86. What is the difference between the Expenses (% of total expenses) in Congo (Republic) in 2004 and the Expenses (% of total expenses) in Kuwait in 2005?
Provide a succinct answer. -21.42. What is the difference between the Expenses (% of total expenses) in Congo (Republic) in 2004 and the Expenses (% of total expenses) in Poland in 2005?
Provide a succinct answer. -7.87. What is the difference between the Expenses (% of total expenses) in Hungary in 2004 and the Expenses (% of total expenses) in Kuwait in 2005?
Your response must be concise. -11.88. What is the difference between the Expenses (% of total expenses) in Hungary in 2004 and the Expenses (% of total expenses) in Poland in 2005?
Offer a very short reply. 1.67. What is the difference between the Expenses (% of total expenses) in Kuwait in 2004 and the Expenses (% of total expenses) in Poland in 2005?
Ensure brevity in your answer.  5.1. What is the difference between the Expenses (% of total expenses) of Congo (Republic) in 2004 and the Expenses (% of total expenses) of Hungary in 2006?
Make the answer very short. -9.64. What is the difference between the Expenses (% of total expenses) of Congo (Republic) in 2004 and the Expenses (% of total expenses) of Kuwait in 2006?
Give a very brief answer. -20.99. What is the difference between the Expenses (% of total expenses) in Congo (Republic) in 2004 and the Expenses (% of total expenses) in Poland in 2006?
Your response must be concise. -7.61. What is the difference between the Expenses (% of total expenses) of Hungary in 2004 and the Expenses (% of total expenses) of Kuwait in 2006?
Provide a succinct answer. -11.46. What is the difference between the Expenses (% of total expenses) in Hungary in 2004 and the Expenses (% of total expenses) in Poland in 2006?
Offer a terse response. 1.92. What is the difference between the Expenses (% of total expenses) in Kuwait in 2004 and the Expenses (% of total expenses) in Poland in 2006?
Ensure brevity in your answer.  5.35. What is the difference between the Expenses (% of total expenses) of Congo (Republic) in 2004 and the Expenses (% of total expenses) of Hungary in 2007?
Provide a short and direct response. -10.45. What is the difference between the Expenses (% of total expenses) of Congo (Republic) in 2004 and the Expenses (% of total expenses) of Kuwait in 2007?
Keep it short and to the point. -23.98. What is the difference between the Expenses (% of total expenses) of Congo (Republic) in 2004 and the Expenses (% of total expenses) of Poland in 2007?
Keep it short and to the point. -7.22. What is the difference between the Expenses (% of total expenses) in Hungary in 2004 and the Expenses (% of total expenses) in Kuwait in 2007?
Provide a short and direct response. -14.45. What is the difference between the Expenses (% of total expenses) of Hungary in 2004 and the Expenses (% of total expenses) of Poland in 2007?
Keep it short and to the point. 2.31. What is the difference between the Expenses (% of total expenses) in Kuwait in 2004 and the Expenses (% of total expenses) in Poland in 2007?
Make the answer very short. 5.74. What is the difference between the Expenses (% of total expenses) of Congo (Republic) in 2004 and the Expenses (% of total expenses) of Hungary in 2008?
Provide a succinct answer. -8.64. What is the difference between the Expenses (% of total expenses) of Congo (Republic) in 2004 and the Expenses (% of total expenses) of Kuwait in 2008?
Offer a very short reply. -15.16. What is the difference between the Expenses (% of total expenses) of Congo (Republic) in 2004 and the Expenses (% of total expenses) of Poland in 2008?
Offer a very short reply. -7.37. What is the difference between the Expenses (% of total expenses) of Hungary in 2004 and the Expenses (% of total expenses) of Kuwait in 2008?
Offer a very short reply. -5.63. What is the difference between the Expenses (% of total expenses) of Hungary in 2004 and the Expenses (% of total expenses) of Poland in 2008?
Provide a succinct answer. 2.16. What is the difference between the Expenses (% of total expenses) of Kuwait in 2004 and the Expenses (% of total expenses) of Poland in 2008?
Ensure brevity in your answer.  5.59. What is the difference between the Expenses (% of total expenses) in Congo (Republic) in 2005 and the Expenses (% of total expenses) in Hungary in 2006?
Provide a succinct answer. -9.63. What is the difference between the Expenses (% of total expenses) of Congo (Republic) in 2005 and the Expenses (% of total expenses) of Kuwait in 2006?
Ensure brevity in your answer.  -20.99. What is the difference between the Expenses (% of total expenses) of Congo (Republic) in 2005 and the Expenses (% of total expenses) of Poland in 2006?
Give a very brief answer. -7.6. What is the difference between the Expenses (% of total expenses) of Hungary in 2005 and the Expenses (% of total expenses) of Kuwait in 2006?
Provide a short and direct response. -12.14. What is the difference between the Expenses (% of total expenses) of Hungary in 2005 and the Expenses (% of total expenses) of Poland in 2006?
Your answer should be compact. 1.25. What is the difference between the Expenses (% of total expenses) in Kuwait in 2005 and the Expenses (% of total expenses) in Poland in 2006?
Offer a very short reply. 13.8. What is the difference between the Expenses (% of total expenses) in Congo (Republic) in 2005 and the Expenses (% of total expenses) in Hungary in 2007?
Provide a short and direct response. -10.44. What is the difference between the Expenses (% of total expenses) in Congo (Republic) in 2005 and the Expenses (% of total expenses) in Kuwait in 2007?
Offer a terse response. -23.97. What is the difference between the Expenses (% of total expenses) in Congo (Republic) in 2005 and the Expenses (% of total expenses) in Poland in 2007?
Ensure brevity in your answer.  -7.21. What is the difference between the Expenses (% of total expenses) in Hungary in 2005 and the Expenses (% of total expenses) in Kuwait in 2007?
Keep it short and to the point. -15.12. What is the difference between the Expenses (% of total expenses) of Hungary in 2005 and the Expenses (% of total expenses) of Poland in 2007?
Provide a succinct answer. 1.64. What is the difference between the Expenses (% of total expenses) in Kuwait in 2005 and the Expenses (% of total expenses) in Poland in 2007?
Keep it short and to the point. 14.19. What is the difference between the Expenses (% of total expenses) of Congo (Republic) in 2005 and the Expenses (% of total expenses) of Hungary in 2008?
Make the answer very short. -8.63. What is the difference between the Expenses (% of total expenses) in Congo (Republic) in 2005 and the Expenses (% of total expenses) in Kuwait in 2008?
Give a very brief answer. -15.15. What is the difference between the Expenses (% of total expenses) in Congo (Republic) in 2005 and the Expenses (% of total expenses) in Poland in 2008?
Provide a short and direct response. -7.36. What is the difference between the Expenses (% of total expenses) in Hungary in 2005 and the Expenses (% of total expenses) in Kuwait in 2008?
Make the answer very short. -6.3. What is the difference between the Expenses (% of total expenses) of Hungary in 2005 and the Expenses (% of total expenses) of Poland in 2008?
Your response must be concise. 1.49. What is the difference between the Expenses (% of total expenses) of Kuwait in 2005 and the Expenses (% of total expenses) of Poland in 2008?
Your response must be concise. 14.05. What is the difference between the Expenses (% of total expenses) of Congo (Republic) in 2006 and the Expenses (% of total expenses) of Hungary in 2007?
Your response must be concise. -8.41. What is the difference between the Expenses (% of total expenses) of Congo (Republic) in 2006 and the Expenses (% of total expenses) of Kuwait in 2007?
Your answer should be compact. -21.93. What is the difference between the Expenses (% of total expenses) in Congo (Republic) in 2006 and the Expenses (% of total expenses) in Poland in 2007?
Make the answer very short. -5.18. What is the difference between the Expenses (% of total expenses) of Hungary in 2006 and the Expenses (% of total expenses) of Kuwait in 2007?
Your answer should be compact. -14.34. What is the difference between the Expenses (% of total expenses) in Hungary in 2006 and the Expenses (% of total expenses) in Poland in 2007?
Give a very brief answer. 2.42. What is the difference between the Expenses (% of total expenses) in Kuwait in 2006 and the Expenses (% of total expenses) in Poland in 2007?
Provide a short and direct response. 13.77. What is the difference between the Expenses (% of total expenses) of Congo (Republic) in 2006 and the Expenses (% of total expenses) of Hungary in 2008?
Your answer should be very brief. -6.59. What is the difference between the Expenses (% of total expenses) of Congo (Republic) in 2006 and the Expenses (% of total expenses) of Kuwait in 2008?
Offer a very short reply. -13.12. What is the difference between the Expenses (% of total expenses) of Congo (Republic) in 2006 and the Expenses (% of total expenses) of Poland in 2008?
Keep it short and to the point. -5.33. What is the difference between the Expenses (% of total expenses) of Hungary in 2006 and the Expenses (% of total expenses) of Kuwait in 2008?
Keep it short and to the point. -5.52. What is the difference between the Expenses (% of total expenses) of Hungary in 2006 and the Expenses (% of total expenses) of Poland in 2008?
Offer a very short reply. 2.27. What is the difference between the Expenses (% of total expenses) of Kuwait in 2006 and the Expenses (% of total expenses) of Poland in 2008?
Make the answer very short. 13.62. What is the difference between the Expenses (% of total expenses) of Congo (Republic) in 2007 and the Expenses (% of total expenses) of Hungary in 2008?
Make the answer very short. -2.38. What is the difference between the Expenses (% of total expenses) in Congo (Republic) in 2007 and the Expenses (% of total expenses) in Kuwait in 2008?
Offer a terse response. -8.91. What is the difference between the Expenses (% of total expenses) of Congo (Republic) in 2007 and the Expenses (% of total expenses) of Poland in 2008?
Give a very brief answer. -1.12. What is the difference between the Expenses (% of total expenses) of Hungary in 2007 and the Expenses (% of total expenses) of Kuwait in 2008?
Offer a terse response. -4.71. What is the difference between the Expenses (% of total expenses) of Hungary in 2007 and the Expenses (% of total expenses) of Poland in 2008?
Your answer should be compact. 3.08. What is the difference between the Expenses (% of total expenses) of Kuwait in 2007 and the Expenses (% of total expenses) of Poland in 2008?
Your answer should be compact. 16.61. What is the average Expenses (% of total expenses) of Congo (Republic) per year?
Your answer should be compact. 1.94. What is the average Expenses (% of total expenses) of Hungary per year?
Provide a succinct answer. 10.87. What is the average Expenses (% of total expenses) in Kuwait per year?
Ensure brevity in your answer.  16.19. What is the average Expenses (% of total expenses) in Poland per year?
Give a very brief answer. 7.57. In the year 2001, what is the difference between the Expenses (% of total expenses) of Congo (Republic) and Expenses (% of total expenses) of Hungary?
Give a very brief answer. -9.36. In the year 2001, what is the difference between the Expenses (% of total expenses) in Congo (Republic) and Expenses (% of total expenses) in Kuwait?
Provide a short and direct response. -6.51. In the year 2001, what is the difference between the Expenses (% of total expenses) of Congo (Republic) and Expenses (% of total expenses) of Poland?
Make the answer very short. -3.79. In the year 2001, what is the difference between the Expenses (% of total expenses) in Hungary and Expenses (% of total expenses) in Kuwait?
Provide a short and direct response. 2.85. In the year 2001, what is the difference between the Expenses (% of total expenses) of Hungary and Expenses (% of total expenses) of Poland?
Give a very brief answer. 5.56. In the year 2001, what is the difference between the Expenses (% of total expenses) of Kuwait and Expenses (% of total expenses) of Poland?
Offer a very short reply. 2.72. In the year 2002, what is the difference between the Expenses (% of total expenses) of Congo (Republic) and Expenses (% of total expenses) of Hungary?
Offer a very short reply. -15.24. In the year 2002, what is the difference between the Expenses (% of total expenses) in Congo (Republic) and Expenses (% of total expenses) in Kuwait?
Your answer should be very brief. -11.24. In the year 2002, what is the difference between the Expenses (% of total expenses) of Congo (Republic) and Expenses (% of total expenses) of Poland?
Offer a very short reply. -6.44. In the year 2002, what is the difference between the Expenses (% of total expenses) in Hungary and Expenses (% of total expenses) in Kuwait?
Your answer should be compact. 4. In the year 2002, what is the difference between the Expenses (% of total expenses) in Hungary and Expenses (% of total expenses) in Poland?
Your response must be concise. 8.8. In the year 2002, what is the difference between the Expenses (% of total expenses) of Kuwait and Expenses (% of total expenses) of Poland?
Keep it short and to the point. 4.81. In the year 2003, what is the difference between the Expenses (% of total expenses) of Congo (Republic) and Expenses (% of total expenses) of Hungary?
Your answer should be very brief. -10.22. In the year 2003, what is the difference between the Expenses (% of total expenses) of Congo (Republic) and Expenses (% of total expenses) of Kuwait?
Ensure brevity in your answer.  -12.16. In the year 2003, what is the difference between the Expenses (% of total expenses) of Congo (Republic) and Expenses (% of total expenses) of Poland?
Provide a succinct answer. -7.08. In the year 2003, what is the difference between the Expenses (% of total expenses) of Hungary and Expenses (% of total expenses) of Kuwait?
Your answer should be very brief. -1.94. In the year 2003, what is the difference between the Expenses (% of total expenses) in Hungary and Expenses (% of total expenses) in Poland?
Your answer should be compact. 3.15. In the year 2003, what is the difference between the Expenses (% of total expenses) in Kuwait and Expenses (% of total expenses) in Poland?
Keep it short and to the point. 5.09. In the year 2004, what is the difference between the Expenses (% of total expenses) of Congo (Republic) and Expenses (% of total expenses) of Hungary?
Keep it short and to the point. -9.53. In the year 2004, what is the difference between the Expenses (% of total expenses) of Congo (Republic) and Expenses (% of total expenses) of Kuwait?
Provide a succinct answer. -12.96. In the year 2004, what is the difference between the Expenses (% of total expenses) in Congo (Republic) and Expenses (% of total expenses) in Poland?
Give a very brief answer. -8.12. In the year 2004, what is the difference between the Expenses (% of total expenses) in Hungary and Expenses (% of total expenses) in Kuwait?
Offer a very short reply. -3.43. In the year 2004, what is the difference between the Expenses (% of total expenses) of Hungary and Expenses (% of total expenses) of Poland?
Give a very brief answer. 1.41. In the year 2004, what is the difference between the Expenses (% of total expenses) in Kuwait and Expenses (% of total expenses) in Poland?
Provide a short and direct response. 4.84. In the year 2005, what is the difference between the Expenses (% of total expenses) in Congo (Republic) and Expenses (% of total expenses) in Hungary?
Make the answer very short. -8.85. In the year 2005, what is the difference between the Expenses (% of total expenses) in Congo (Republic) and Expenses (% of total expenses) in Kuwait?
Provide a succinct answer. -21.41. In the year 2005, what is the difference between the Expenses (% of total expenses) in Congo (Republic) and Expenses (% of total expenses) in Poland?
Your response must be concise. -7.86. In the year 2005, what is the difference between the Expenses (% of total expenses) of Hungary and Expenses (% of total expenses) of Kuwait?
Ensure brevity in your answer.  -12.56. In the year 2005, what is the difference between the Expenses (% of total expenses) of Kuwait and Expenses (% of total expenses) of Poland?
Offer a terse response. 13.55. In the year 2006, what is the difference between the Expenses (% of total expenses) of Congo (Republic) and Expenses (% of total expenses) of Hungary?
Keep it short and to the point. -7.59. In the year 2006, what is the difference between the Expenses (% of total expenses) of Congo (Republic) and Expenses (% of total expenses) of Kuwait?
Offer a terse response. -18.95. In the year 2006, what is the difference between the Expenses (% of total expenses) in Congo (Republic) and Expenses (% of total expenses) in Poland?
Offer a terse response. -5.57. In the year 2006, what is the difference between the Expenses (% of total expenses) in Hungary and Expenses (% of total expenses) in Kuwait?
Your response must be concise. -11.36. In the year 2006, what is the difference between the Expenses (% of total expenses) of Hungary and Expenses (% of total expenses) of Poland?
Make the answer very short. 2.03. In the year 2006, what is the difference between the Expenses (% of total expenses) of Kuwait and Expenses (% of total expenses) of Poland?
Offer a terse response. 13.38. In the year 2007, what is the difference between the Expenses (% of total expenses) in Congo (Republic) and Expenses (% of total expenses) in Hungary?
Your answer should be very brief. -4.2. In the year 2007, what is the difference between the Expenses (% of total expenses) of Congo (Republic) and Expenses (% of total expenses) of Kuwait?
Give a very brief answer. -17.73. In the year 2007, what is the difference between the Expenses (% of total expenses) of Congo (Republic) and Expenses (% of total expenses) of Poland?
Make the answer very short. -0.97. In the year 2007, what is the difference between the Expenses (% of total expenses) in Hungary and Expenses (% of total expenses) in Kuwait?
Your response must be concise. -13.53. In the year 2007, what is the difference between the Expenses (% of total expenses) in Hungary and Expenses (% of total expenses) in Poland?
Your answer should be very brief. 3.23. In the year 2007, what is the difference between the Expenses (% of total expenses) in Kuwait and Expenses (% of total expenses) in Poland?
Offer a terse response. 16.76. In the year 2008, what is the difference between the Expenses (% of total expenses) of Congo (Republic) and Expenses (% of total expenses) of Hungary?
Make the answer very short. -6.5. In the year 2008, what is the difference between the Expenses (% of total expenses) of Congo (Republic) and Expenses (% of total expenses) of Kuwait?
Ensure brevity in your answer.  -13.02. In the year 2008, what is the difference between the Expenses (% of total expenses) in Congo (Republic) and Expenses (% of total expenses) in Poland?
Provide a succinct answer. -5.23. In the year 2008, what is the difference between the Expenses (% of total expenses) in Hungary and Expenses (% of total expenses) in Kuwait?
Provide a succinct answer. -6.52. In the year 2008, what is the difference between the Expenses (% of total expenses) of Hungary and Expenses (% of total expenses) of Poland?
Give a very brief answer. 1.27. In the year 2008, what is the difference between the Expenses (% of total expenses) in Kuwait and Expenses (% of total expenses) in Poland?
Provide a succinct answer. 7.79. What is the ratio of the Expenses (% of total expenses) of Congo (Republic) in 2001 to that in 2002?
Your answer should be very brief. 8.69. What is the ratio of the Expenses (% of total expenses) of Hungary in 2001 to that in 2002?
Make the answer very short. 0.85. What is the ratio of the Expenses (% of total expenses) in Kuwait in 2001 to that in 2002?
Provide a succinct answer. 0.9. What is the ratio of the Expenses (% of total expenses) in Poland in 2001 to that in 2002?
Keep it short and to the point. 1.14. What is the ratio of the Expenses (% of total expenses) in Congo (Republic) in 2001 to that in 2003?
Keep it short and to the point. 10.75. What is the ratio of the Expenses (% of total expenses) in Hungary in 2001 to that in 2003?
Make the answer very short. 1.26. What is the ratio of the Expenses (% of total expenses) of Kuwait in 2001 to that in 2003?
Make the answer very short. 0.84. What is the ratio of the Expenses (% of total expenses) in Poland in 2001 to that in 2003?
Ensure brevity in your answer.  1.05. What is the ratio of the Expenses (% of total expenses) in Congo (Republic) in 2001 to that in 2004?
Your response must be concise. 119.51. What is the ratio of the Expenses (% of total expenses) in Hungary in 2001 to that in 2004?
Give a very brief answer. 1.4. What is the ratio of the Expenses (% of total expenses) in Kuwait in 2001 to that in 2004?
Provide a short and direct response. 0.81. What is the ratio of the Expenses (% of total expenses) of Poland in 2001 to that in 2004?
Ensure brevity in your answer.  0.96. What is the ratio of the Expenses (% of total expenses) in Congo (Republic) in 2001 to that in 2005?
Provide a succinct answer. 96.93. What is the ratio of the Expenses (% of total expenses) in Hungary in 2001 to that in 2005?
Your response must be concise. 1.51. What is the ratio of the Expenses (% of total expenses) in Kuwait in 2001 to that in 2005?
Your answer should be very brief. 0.49. What is the ratio of the Expenses (% of total expenses) of Congo (Republic) in 2001 to that in 2006?
Keep it short and to the point. 1.95. What is the ratio of the Expenses (% of total expenses) in Hungary in 2001 to that in 2006?
Offer a terse response. 1.39. What is the ratio of the Expenses (% of total expenses) in Kuwait in 2001 to that in 2006?
Your response must be concise. 0.5. What is the ratio of the Expenses (% of total expenses) in Poland in 2001 to that in 2006?
Provide a succinct answer. 1.03. What is the ratio of the Expenses (% of total expenses) of Congo (Republic) in 2001 to that in 2007?
Your answer should be very brief. 0.64. What is the ratio of the Expenses (% of total expenses) of Hungary in 2001 to that in 2007?
Make the answer very short. 1.28. What is the ratio of the Expenses (% of total expenses) in Kuwait in 2001 to that in 2007?
Ensure brevity in your answer.  0.44. What is the ratio of the Expenses (% of total expenses) of Poland in 2001 to that in 2007?
Your answer should be very brief. 1.08. What is the ratio of the Expenses (% of total expenses) of Congo (Republic) in 2001 to that in 2008?
Provide a short and direct response. 1.86. What is the ratio of the Expenses (% of total expenses) of Hungary in 2001 to that in 2008?
Your answer should be very brief. 1.55. What is the ratio of the Expenses (% of total expenses) in Kuwait in 2001 to that in 2008?
Your answer should be compact. 0.69. What is the ratio of the Expenses (% of total expenses) in Poland in 2001 to that in 2008?
Keep it short and to the point. 1.06. What is the ratio of the Expenses (% of total expenses) in Congo (Republic) in 2002 to that in 2003?
Offer a very short reply. 1.24. What is the ratio of the Expenses (% of total expenses) of Hungary in 2002 to that in 2003?
Ensure brevity in your answer.  1.48. What is the ratio of the Expenses (% of total expenses) of Kuwait in 2002 to that in 2003?
Provide a succinct answer. 0.93. What is the ratio of the Expenses (% of total expenses) of Poland in 2002 to that in 2003?
Your answer should be compact. 0.93. What is the ratio of the Expenses (% of total expenses) of Congo (Republic) in 2002 to that in 2004?
Offer a very short reply. 13.75. What is the ratio of the Expenses (% of total expenses) in Hungary in 2002 to that in 2004?
Ensure brevity in your answer.  1.64. What is the ratio of the Expenses (% of total expenses) of Kuwait in 2002 to that in 2004?
Your answer should be compact. 0.9. What is the ratio of the Expenses (% of total expenses) in Poland in 2002 to that in 2004?
Give a very brief answer. 0.85. What is the ratio of the Expenses (% of total expenses) in Congo (Republic) in 2002 to that in 2005?
Your answer should be very brief. 11.15. What is the ratio of the Expenses (% of total expenses) of Hungary in 2002 to that in 2005?
Make the answer very short. 1.77. What is the ratio of the Expenses (% of total expenses) in Kuwait in 2002 to that in 2005?
Your response must be concise. 0.55. What is the ratio of the Expenses (% of total expenses) of Poland in 2002 to that in 2005?
Your response must be concise. 0.87. What is the ratio of the Expenses (% of total expenses) in Congo (Republic) in 2002 to that in 2006?
Make the answer very short. 0.22. What is the ratio of the Expenses (% of total expenses) of Hungary in 2002 to that in 2006?
Your answer should be compact. 1.62. What is the ratio of the Expenses (% of total expenses) of Kuwait in 2002 to that in 2006?
Give a very brief answer. 0.56. What is the ratio of the Expenses (% of total expenses) of Poland in 2002 to that in 2006?
Give a very brief answer. 0.9. What is the ratio of the Expenses (% of total expenses) in Congo (Republic) in 2002 to that in 2007?
Offer a terse response. 0.07. What is the ratio of the Expenses (% of total expenses) of Hungary in 2002 to that in 2007?
Your response must be concise. 1.5. What is the ratio of the Expenses (% of total expenses) in Kuwait in 2002 to that in 2007?
Ensure brevity in your answer.  0.49. What is the ratio of the Expenses (% of total expenses) of Poland in 2002 to that in 2007?
Your answer should be compact. 0.95. What is the ratio of the Expenses (% of total expenses) of Congo (Republic) in 2002 to that in 2008?
Offer a terse response. 0.21. What is the ratio of the Expenses (% of total expenses) of Hungary in 2002 to that in 2008?
Your response must be concise. 1.81. What is the ratio of the Expenses (% of total expenses) of Kuwait in 2002 to that in 2008?
Keep it short and to the point. 0.77. What is the ratio of the Expenses (% of total expenses) in Poland in 2002 to that in 2008?
Provide a succinct answer. 0.93. What is the ratio of the Expenses (% of total expenses) in Congo (Republic) in 2003 to that in 2004?
Offer a very short reply. 11.12. What is the ratio of the Expenses (% of total expenses) in Hungary in 2003 to that in 2004?
Ensure brevity in your answer.  1.11. What is the ratio of the Expenses (% of total expenses) of Kuwait in 2003 to that in 2004?
Make the answer very short. 0.96. What is the ratio of the Expenses (% of total expenses) of Poland in 2003 to that in 2004?
Offer a very short reply. 0.91. What is the ratio of the Expenses (% of total expenses) in Congo (Republic) in 2003 to that in 2005?
Make the answer very short. 9.02. What is the ratio of the Expenses (% of total expenses) of Hungary in 2003 to that in 2005?
Offer a very short reply. 1.19. What is the ratio of the Expenses (% of total expenses) in Kuwait in 2003 to that in 2005?
Keep it short and to the point. 0.58. What is the ratio of the Expenses (% of total expenses) in Poland in 2003 to that in 2005?
Offer a very short reply. 0.94. What is the ratio of the Expenses (% of total expenses) of Congo (Republic) in 2003 to that in 2006?
Offer a terse response. 0.18. What is the ratio of the Expenses (% of total expenses) of Hungary in 2003 to that in 2006?
Offer a very short reply. 1.1. What is the ratio of the Expenses (% of total expenses) of Kuwait in 2003 to that in 2006?
Offer a very short reply. 0.6. What is the ratio of the Expenses (% of total expenses) in Poland in 2003 to that in 2006?
Make the answer very short. 0.97. What is the ratio of the Expenses (% of total expenses) of Congo (Republic) in 2003 to that in 2007?
Your answer should be very brief. 0.06. What is the ratio of the Expenses (% of total expenses) in Hungary in 2003 to that in 2007?
Provide a short and direct response. 1.01. What is the ratio of the Expenses (% of total expenses) in Kuwait in 2003 to that in 2007?
Keep it short and to the point. 0.52. What is the ratio of the Expenses (% of total expenses) of Poland in 2003 to that in 2007?
Offer a very short reply. 1.03. What is the ratio of the Expenses (% of total expenses) of Congo (Republic) in 2003 to that in 2008?
Ensure brevity in your answer.  0.17. What is the ratio of the Expenses (% of total expenses) of Hungary in 2003 to that in 2008?
Provide a short and direct response. 1.22. What is the ratio of the Expenses (% of total expenses) in Kuwait in 2003 to that in 2008?
Your answer should be very brief. 0.83. What is the ratio of the Expenses (% of total expenses) of Poland in 2003 to that in 2008?
Your response must be concise. 1.01. What is the ratio of the Expenses (% of total expenses) in Congo (Republic) in 2004 to that in 2005?
Your answer should be compact. 0.81. What is the ratio of the Expenses (% of total expenses) of Hungary in 2004 to that in 2005?
Ensure brevity in your answer.  1.08. What is the ratio of the Expenses (% of total expenses) in Kuwait in 2004 to that in 2005?
Your response must be concise. 0.61. What is the ratio of the Expenses (% of total expenses) in Poland in 2004 to that in 2005?
Provide a short and direct response. 1.03. What is the ratio of the Expenses (% of total expenses) in Congo (Republic) in 2004 to that in 2006?
Make the answer very short. 0.02. What is the ratio of the Expenses (% of total expenses) in Hungary in 2004 to that in 2006?
Ensure brevity in your answer.  0.99. What is the ratio of the Expenses (% of total expenses) of Kuwait in 2004 to that in 2006?
Provide a succinct answer. 0.62. What is the ratio of the Expenses (% of total expenses) of Poland in 2004 to that in 2006?
Ensure brevity in your answer.  1.07. What is the ratio of the Expenses (% of total expenses) of Congo (Republic) in 2004 to that in 2007?
Your answer should be very brief. 0.01. What is the ratio of the Expenses (% of total expenses) of Hungary in 2004 to that in 2007?
Your answer should be very brief. 0.91. What is the ratio of the Expenses (% of total expenses) of Kuwait in 2004 to that in 2007?
Your answer should be very brief. 0.54. What is the ratio of the Expenses (% of total expenses) of Poland in 2004 to that in 2007?
Give a very brief answer. 1.12. What is the ratio of the Expenses (% of total expenses) of Congo (Republic) in 2004 to that in 2008?
Offer a very short reply. 0.02. What is the ratio of the Expenses (% of total expenses) of Hungary in 2004 to that in 2008?
Offer a terse response. 1.1. What is the ratio of the Expenses (% of total expenses) of Kuwait in 2004 to that in 2008?
Give a very brief answer. 0.86. What is the ratio of the Expenses (% of total expenses) in Poland in 2004 to that in 2008?
Your answer should be compact. 1.1. What is the ratio of the Expenses (% of total expenses) of Congo (Republic) in 2005 to that in 2006?
Your answer should be compact. 0.02. What is the ratio of the Expenses (% of total expenses) of Hungary in 2005 to that in 2006?
Provide a succinct answer. 0.92. What is the ratio of the Expenses (% of total expenses) in Kuwait in 2005 to that in 2006?
Your response must be concise. 1.02. What is the ratio of the Expenses (% of total expenses) of Poland in 2005 to that in 2006?
Offer a very short reply. 1.03. What is the ratio of the Expenses (% of total expenses) of Congo (Republic) in 2005 to that in 2007?
Give a very brief answer. 0.01. What is the ratio of the Expenses (% of total expenses) in Hungary in 2005 to that in 2007?
Make the answer very short. 0.85. What is the ratio of the Expenses (% of total expenses) of Kuwait in 2005 to that in 2007?
Ensure brevity in your answer.  0.89. What is the ratio of the Expenses (% of total expenses) in Poland in 2005 to that in 2007?
Offer a terse response. 1.09. What is the ratio of the Expenses (% of total expenses) of Congo (Republic) in 2005 to that in 2008?
Provide a succinct answer. 0.02. What is the ratio of the Expenses (% of total expenses) in Hungary in 2005 to that in 2008?
Make the answer very short. 1.03. What is the ratio of the Expenses (% of total expenses) of Kuwait in 2005 to that in 2008?
Your answer should be compact. 1.41. What is the ratio of the Expenses (% of total expenses) in Poland in 2005 to that in 2008?
Make the answer very short. 1.07. What is the ratio of the Expenses (% of total expenses) in Congo (Republic) in 2006 to that in 2007?
Make the answer very short. 0.33. What is the ratio of the Expenses (% of total expenses) in Hungary in 2006 to that in 2007?
Offer a terse response. 0.92. What is the ratio of the Expenses (% of total expenses) in Kuwait in 2006 to that in 2007?
Keep it short and to the point. 0.88. What is the ratio of the Expenses (% of total expenses) in Poland in 2006 to that in 2007?
Your answer should be very brief. 1.05. What is the ratio of the Expenses (% of total expenses) in Congo (Republic) in 2006 to that in 2008?
Give a very brief answer. 0.96. What is the ratio of the Expenses (% of total expenses) of Hungary in 2006 to that in 2008?
Ensure brevity in your answer.  1.12. What is the ratio of the Expenses (% of total expenses) in Kuwait in 2006 to that in 2008?
Provide a succinct answer. 1.38. What is the ratio of the Expenses (% of total expenses) of Poland in 2006 to that in 2008?
Your answer should be very brief. 1.03. What is the ratio of the Expenses (% of total expenses) in Congo (Republic) in 2007 to that in 2008?
Provide a short and direct response. 2.89. What is the ratio of the Expenses (% of total expenses) in Hungary in 2007 to that in 2008?
Give a very brief answer. 1.21. What is the ratio of the Expenses (% of total expenses) of Kuwait in 2007 to that in 2008?
Provide a short and direct response. 1.58. What is the ratio of the Expenses (% of total expenses) in Poland in 2007 to that in 2008?
Offer a very short reply. 0.98. What is the difference between the highest and the second highest Expenses (% of total expenses) in Congo (Republic)?
Provide a succinct answer. 2.24. What is the difference between the highest and the second highest Expenses (% of total expenses) of Hungary?
Offer a very short reply. 2.3. What is the difference between the highest and the second highest Expenses (% of total expenses) in Kuwait?
Ensure brevity in your answer.  2.56. What is the difference between the highest and the second highest Expenses (% of total expenses) in Poland?
Offer a very short reply. 0.26. What is the difference between the highest and the lowest Expenses (% of total expenses) in Congo (Republic)?
Keep it short and to the point. 6.25. What is the difference between the highest and the lowest Expenses (% of total expenses) in Hungary?
Make the answer very short. 7.03. What is the difference between the highest and the lowest Expenses (% of total expenses) of Kuwait?
Ensure brevity in your answer.  13.45. What is the difference between the highest and the lowest Expenses (% of total expenses) in Poland?
Give a very brief answer. 1.25. 